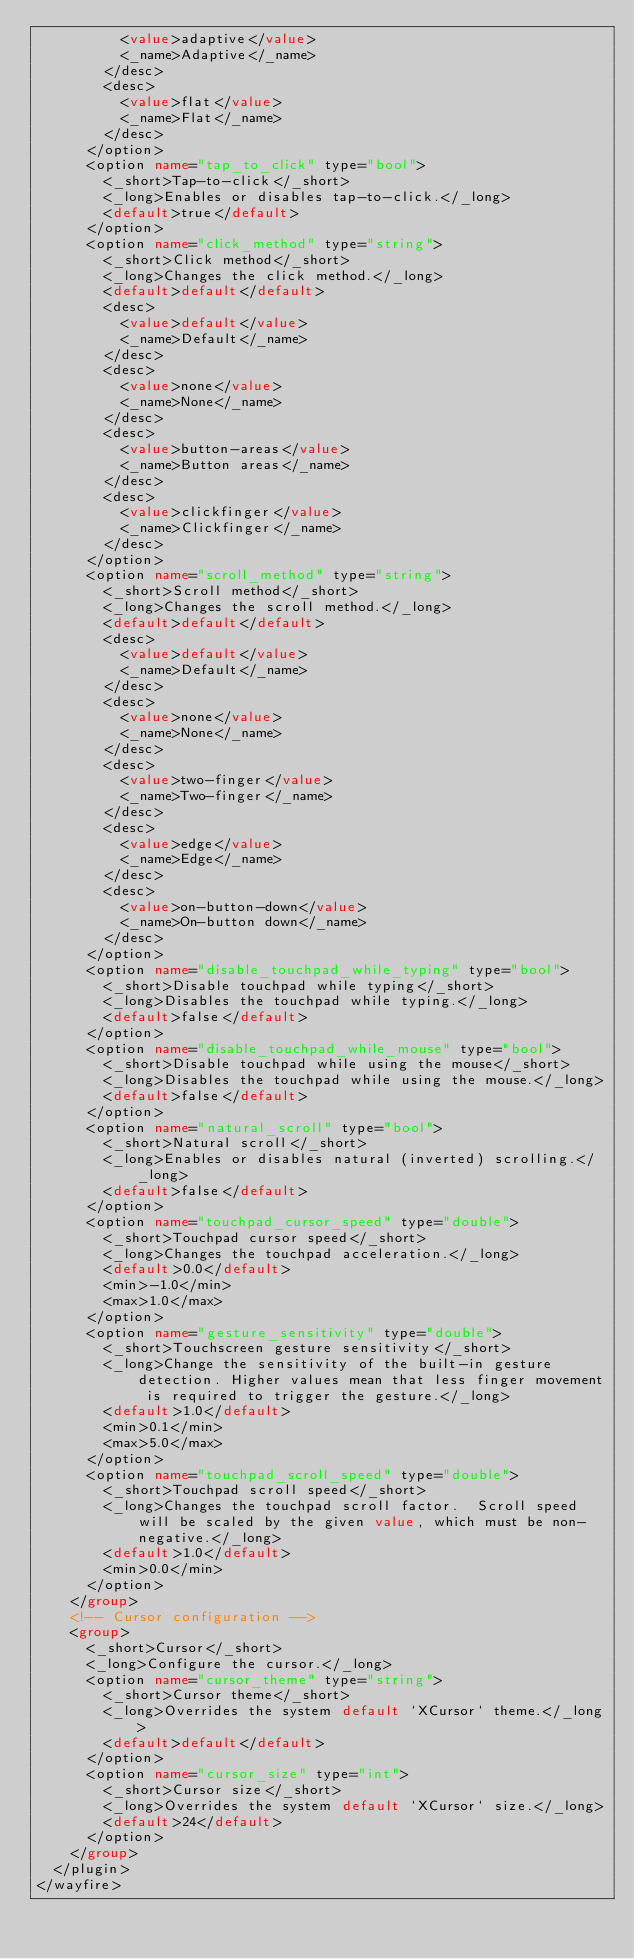<code> <loc_0><loc_0><loc_500><loc_500><_XML_>					<value>adaptive</value>
					<_name>Adaptive</_name>
				</desc>
				<desc>
					<value>flat</value>
					<_name>Flat</_name>
				</desc>
			</option>
			<option name="tap_to_click" type="bool">
				<_short>Tap-to-click</_short>
				<_long>Enables or disables tap-to-click.</_long>
				<default>true</default>
			</option>
			<option name="click_method" type="string">
				<_short>Click method</_short>
				<_long>Changes the click method.</_long>
				<default>default</default>
				<desc>
					<value>default</value>
					<_name>Default</_name>
				</desc>
				<desc>
					<value>none</value>
					<_name>None</_name>
				</desc>
				<desc>
					<value>button-areas</value>
					<_name>Button areas</_name>
				</desc>
				<desc>
					<value>clickfinger</value>
					<_name>Clickfinger</_name>
				</desc>
			</option>
			<option name="scroll_method" type="string">
				<_short>Scroll method</_short>
				<_long>Changes the scroll method.</_long>
				<default>default</default>
				<desc>
					<value>default</value>
					<_name>Default</_name>
				</desc>
				<desc>
					<value>none</value>
					<_name>None</_name>
				</desc>
				<desc>
					<value>two-finger</value>
					<_name>Two-finger</_name>
				</desc>
				<desc>
					<value>edge</value>
					<_name>Edge</_name>
				</desc>
				<desc>
					<value>on-button-down</value>
					<_name>On-button down</_name>
				</desc>
			</option>
			<option name="disable_touchpad_while_typing" type="bool">
				<_short>Disable touchpad while typing</_short>
				<_long>Disables the touchpad while typing.</_long>
				<default>false</default>
			</option>
			<option name="disable_touchpad_while_mouse" type="bool">
				<_short>Disable touchpad while using the mouse</_short>
				<_long>Disables the touchpad while using the mouse.</_long>
				<default>false</default>
			</option>
			<option name="natural_scroll" type="bool">
				<_short>Natural scroll</_short>
				<_long>Enables or disables natural (inverted) scrolling.</_long>
				<default>false</default>
			</option>
			<option name="touchpad_cursor_speed" type="double">
				<_short>Touchpad cursor speed</_short>
				<_long>Changes the touchpad acceleration.</_long>
				<default>0.0</default>
				<min>-1.0</min>
				<max>1.0</max>
			</option>
			<option name="gesture_sensitivity" type="double">
				<_short>Touchscreen gesture sensitivity</_short>
				<_long>Change the sensitivity of the built-in gesture detection. Higher values mean that less finger movement is required to trigger the gesture.</_long>
				<default>1.0</default>
				<min>0.1</min>
				<max>5.0</max>
			</option>
			<option name="touchpad_scroll_speed" type="double">
				<_short>Touchpad scroll speed</_short>
				<_long>Changes the touchpad scroll factor.  Scroll speed will be scaled by the given value, which must be non-negative.</_long>
				<default>1.0</default>
				<min>0.0</min>
			</option>
		</group>
		<!-- Cursor configuration -->
		<group>
			<_short>Cursor</_short>
			<_long>Configure the cursor.</_long>
			<option name="cursor_theme" type="string">
				<_short>Cursor theme</_short>
				<_long>Overrides the system default `XCursor` theme.</_long>
				<default>default</default>
			</option>
			<option name="cursor_size" type="int">
				<_short>Cursor size</_short>
				<_long>Overrides the system default `XCursor` size.</_long>
				<default>24</default>
			</option>
		</group>
	</plugin>
</wayfire>
</code> 